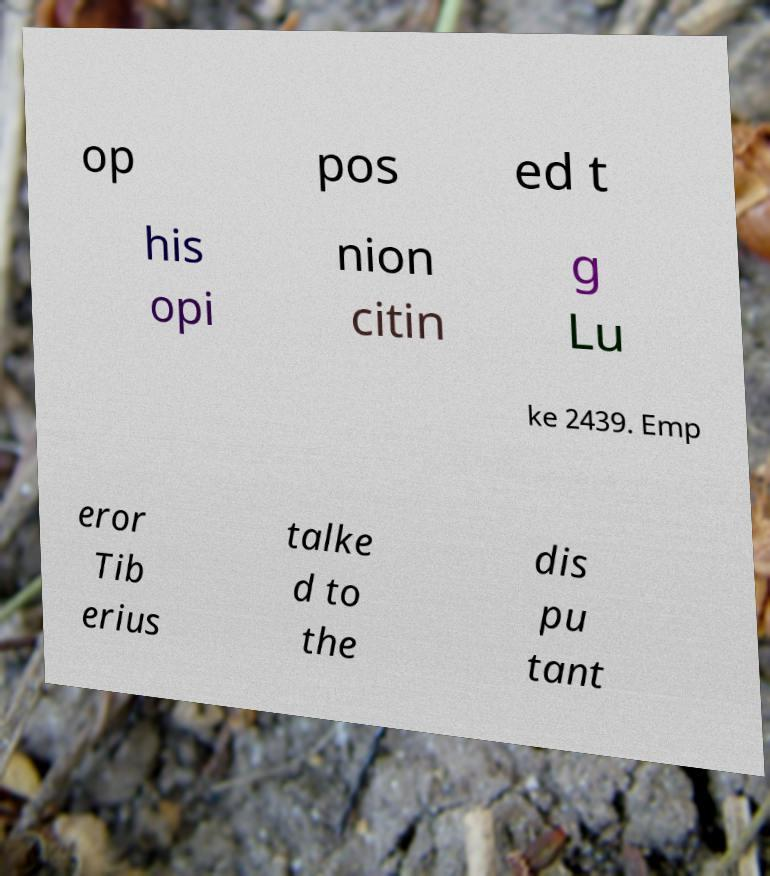Please read and relay the text visible in this image. What does it say? op pos ed t his opi nion citin g Lu ke 2439. Emp eror Tib erius talke d to the dis pu tant 